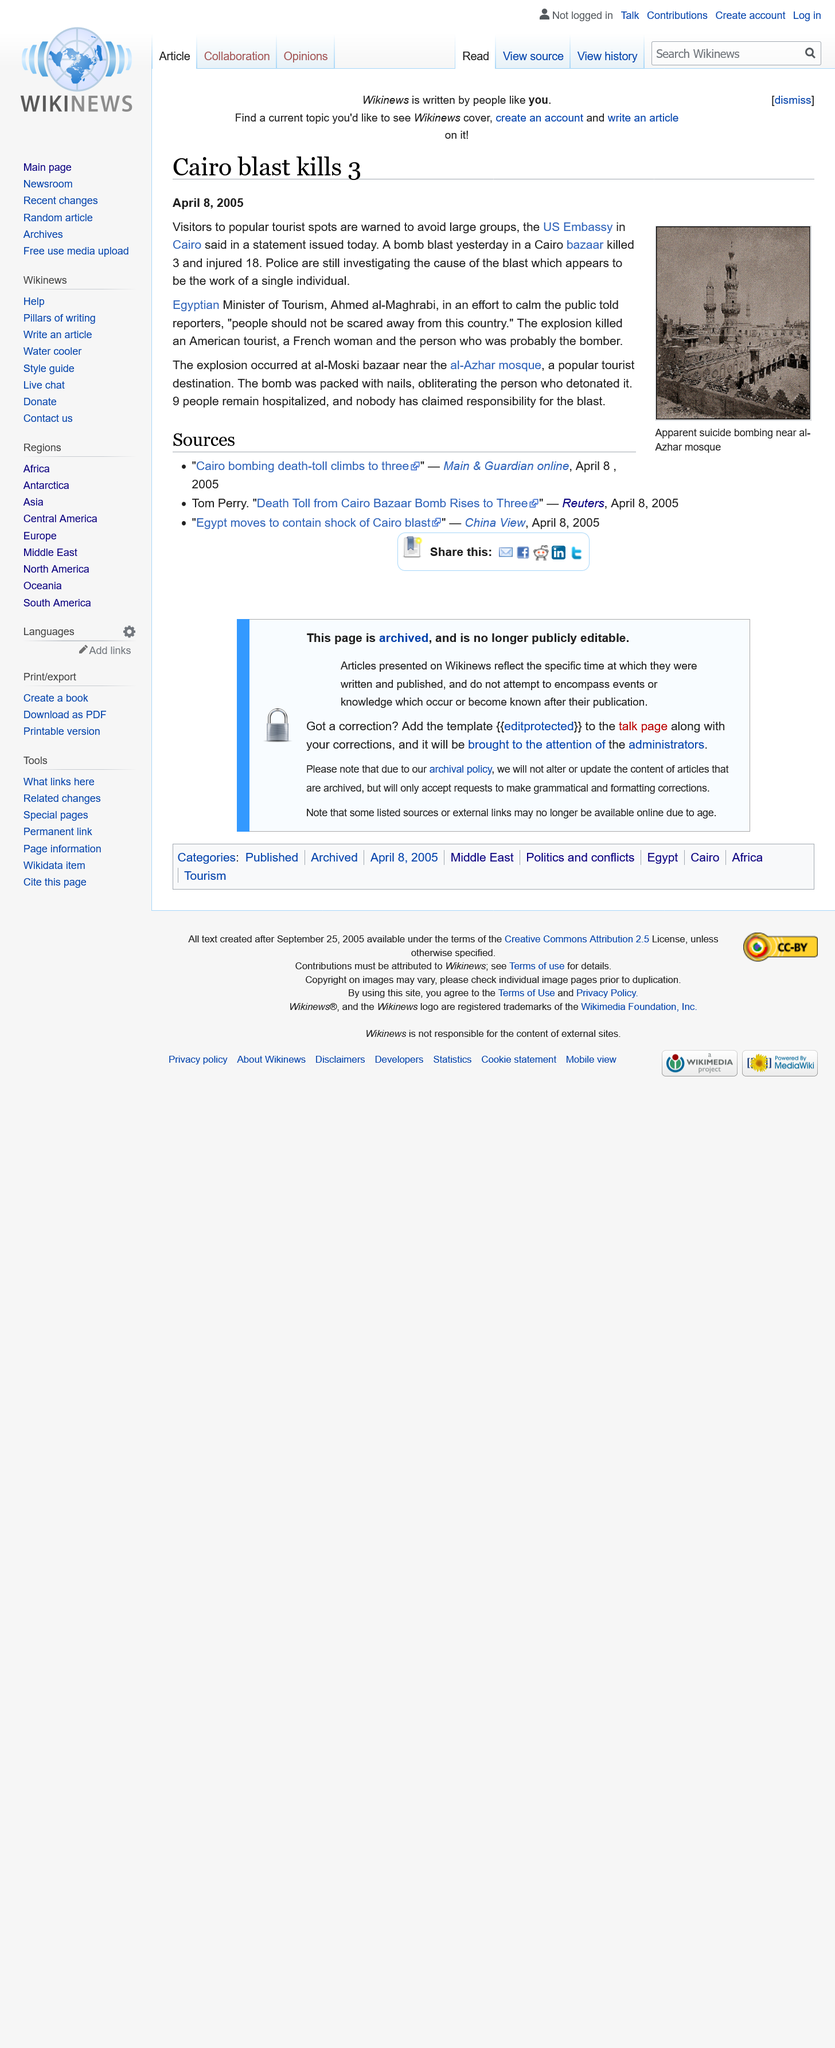Outline some significant characteristics in this image. Three individuals lost their lives as a result of a bomb blast at a Cairo bazaar. The article by Tom Perry was one of the sources cited in the discussion. Ahmed al-Maghrabi is the current Egyptian Minister of Tourism. 